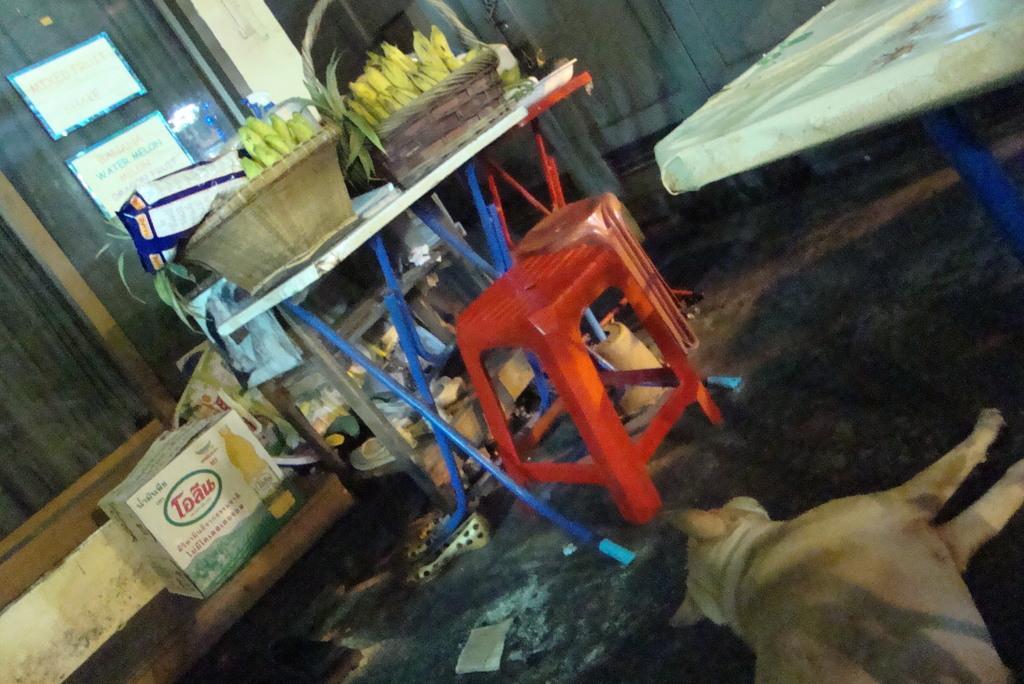In one or two sentences, can you explain what this image depicts? In this image we can see a dog on the surface. We can also see the stools, tables and on the table we can see the banana baskets, a bag. We can also see the flower pot, cardboard box, a glass window with some papers attached to it. We can also see a pair of shoes on the surface. 